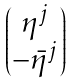Convert formula to latex. <formula><loc_0><loc_0><loc_500><loc_500>\begin{pmatrix} \eta ^ { j } \\ - \bar { \eta } ^ { j } \end{pmatrix}</formula> 